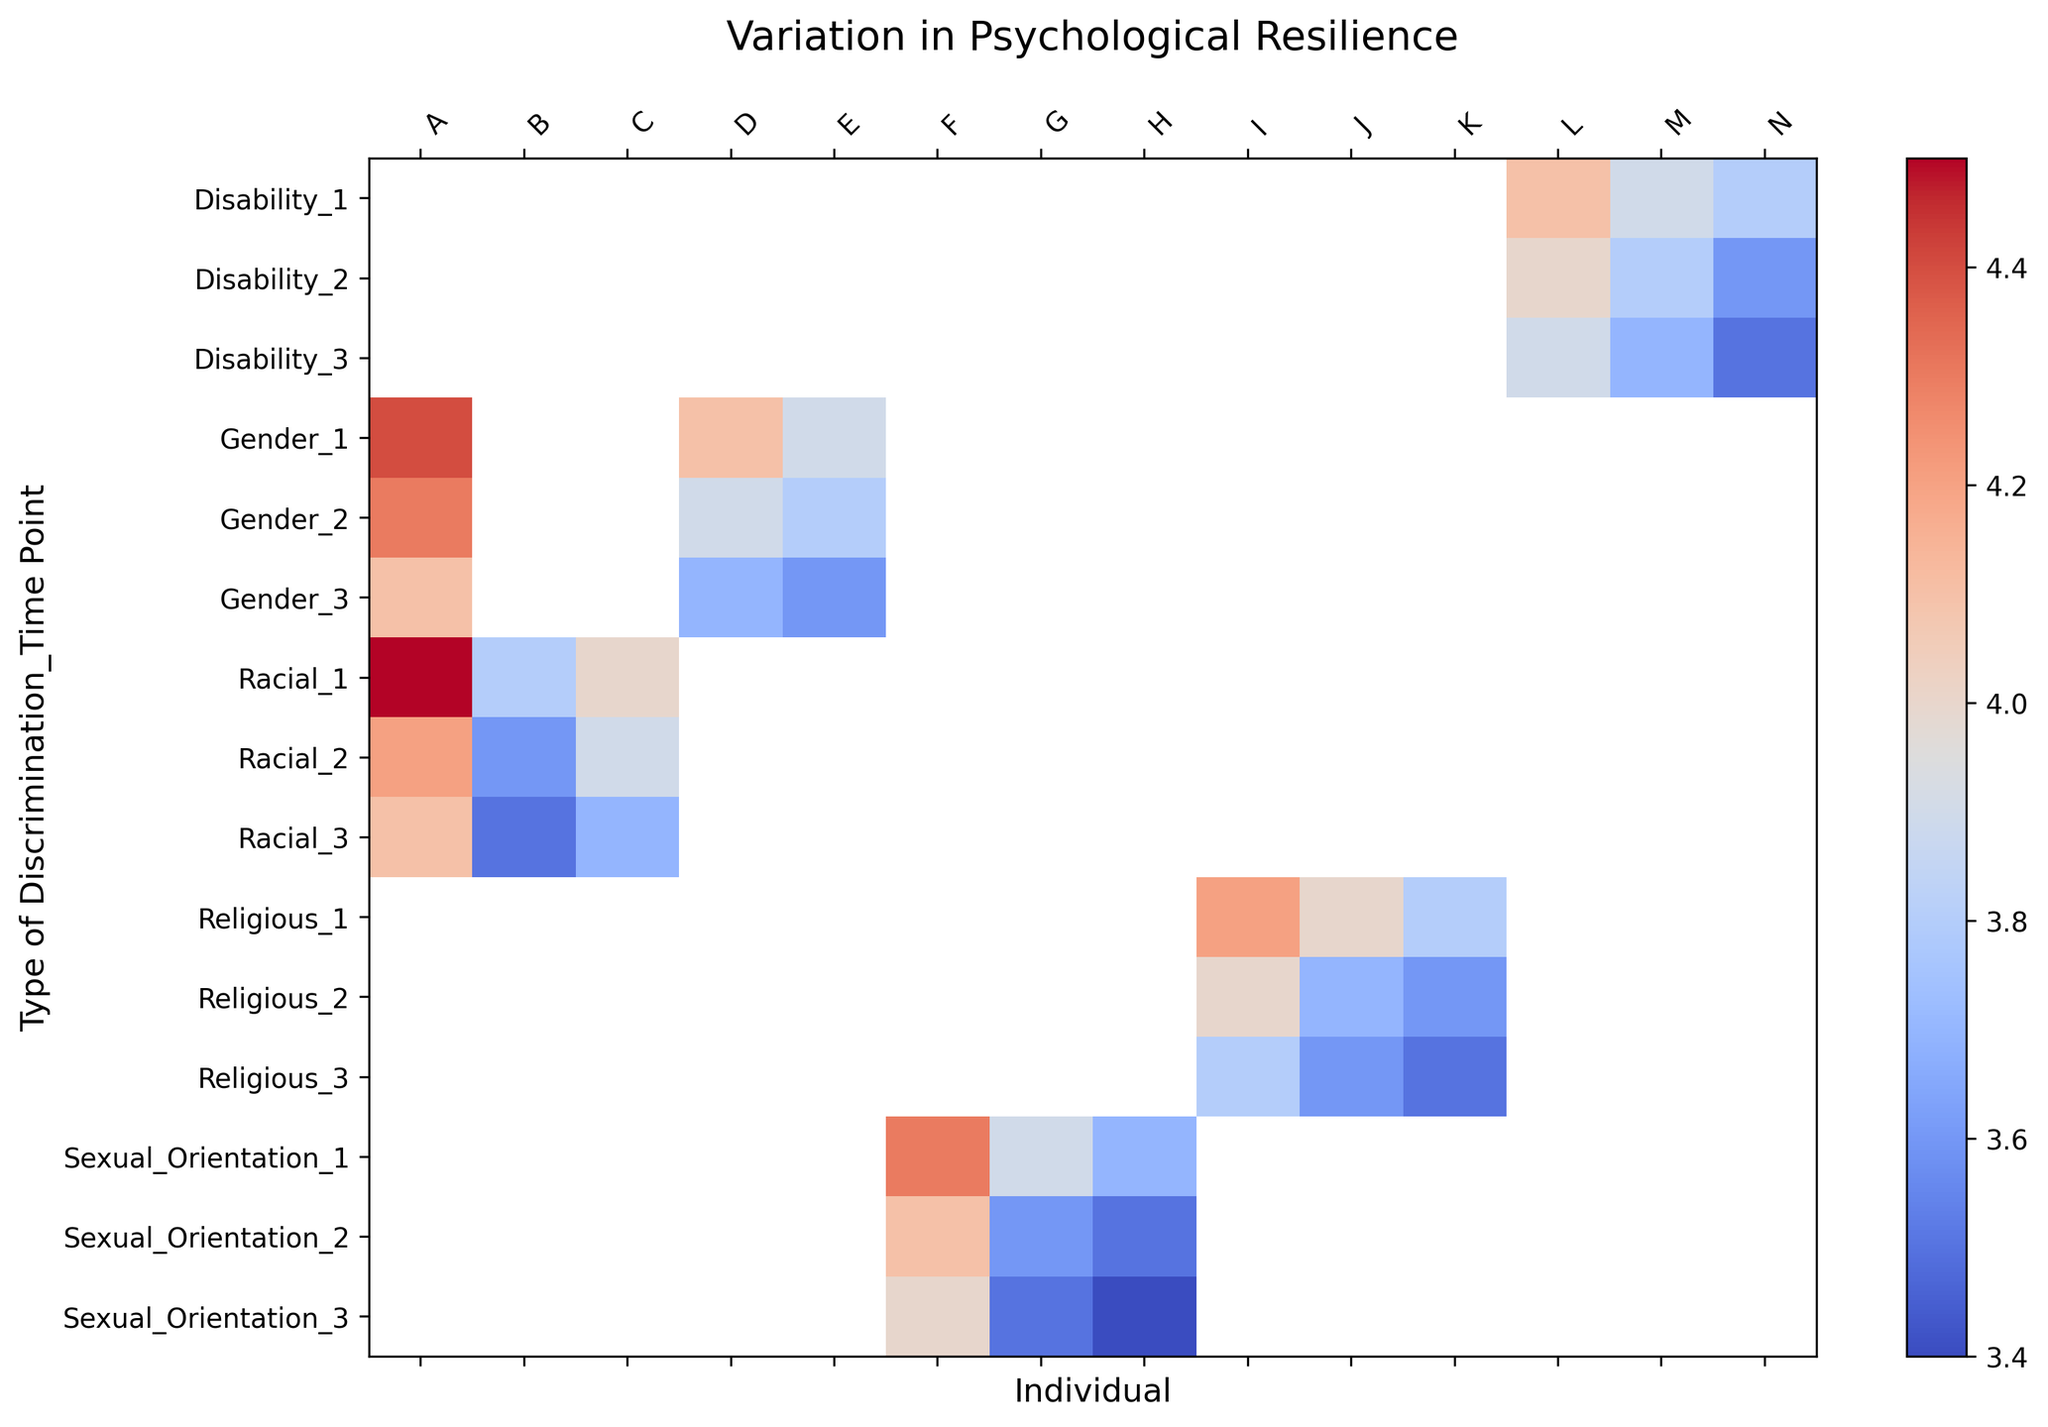Which type of discrimination exhibits the highest resilience score at Time Point 1? Look at the color intensity at Time Point 1 for each type of discrimination. The lightest color (most towards red) indicates the highest resilience score.
Answer: Racial Is there a trend in the resilience scores over time for individuals subjected to racial discrimination? Observe the changes in color intensity for the racial discrimination category over the three time points. If the colors become progressively darker or lighter, there is a trend.
Answer: Scores decrease Which individual consistently shows the highest resilience scores across all forms of discrimination at Time Point 2? Compare the color intensities for all individuals at Time Point 2. Identify the individual with the consistently lightest color (most towards red) across different discrimination types.
Answer: Individual A How does the resilience score of Individual D at Time Point 3 in gender discrimination compare to their score at Time Point 1? Compare the color intensity for Individual D at Time Point 3 with that at Time Point 1 in the gender discrimination row.
Answer: Lower at Time Point 3 Which form of discrimination shows the greatest variation in resilience scores across individuals at Time Point 2? Look at the range of color intensities for different individuals at Time Point 2 across all types of discrimination. The form with the widest range of colors is the one with the greatest variation.
Answer: Racial What is the average resilience score for individuals subjected to disability discrimination at Time Point 3? Sum the resilience scores for Individuals L, M, and N at Time Point 3 for disability discrimination and divide by 3.
Answer: (3.9 + 3.7 + 3.5) / 3 = 3.70 Which individual shows the most significant decrease in resilience scores from Time Point 1 to Time Point 3 in any form of discrimination? Compare the changes in color intensities for all individuals across all types of discrimination from Time Point 1 to Time Point 3. The greatest change from light red to darker color indicates the most significant decrease.
Answer: Individual B Is there any type of discrimination where the resilience score trends are consistent for all individuals over time? Observe each type of discrimination to see if all individuals within a type show the same trend in color intensity (either all increasing or decreasing) over the three time points.
Answer: Yes, Racial (all decreasing) 